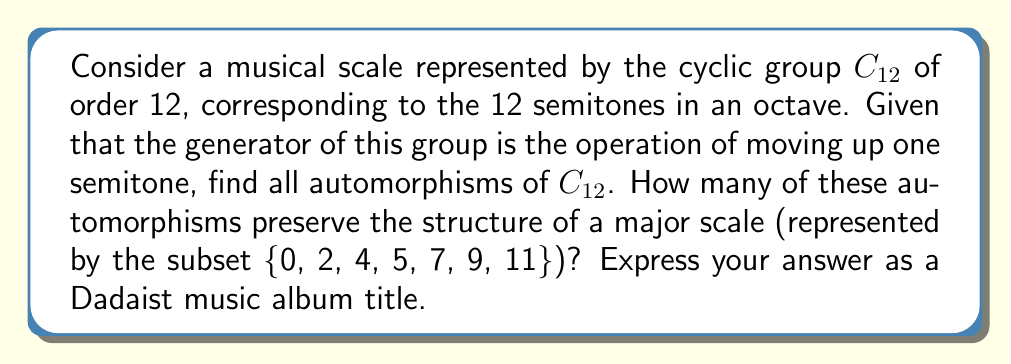Can you solve this math problem? Let's approach this step-by-step:

1) First, recall that for a cyclic group $C_n$, the automorphisms are precisely the mappings $\phi_k: x \mapsto x^k$, where $k$ is coprime to $n$.

2) In our case, $n = 12$. The numbers coprime to 12 are 1, 5, 7, and 11.

3) So, the automorphisms of $C_{12}$ are:
   $\phi_1: x \mapsto x^1 = x$ (the identity automorphism)
   $\phi_5: x \mapsto x^5$
   $\phi_7: x \mapsto x^7$
   $\phi_{11}: x \mapsto x^{11} = x^{-1}$

4) Now, let's consider which of these preserve the structure of a major scale {0, 2, 4, 5, 7, 9, 11}.

   $\phi_1$ obviously preserves it.
   
   $\phi_5$ maps the scale to {0, 10, 8, 1, 11, 9, 7}, which is not a major scale.
   
   $\phi_7$ maps the scale to {0, 2, 4, 11, 1, 3, 5}, which is not a major scale.
   
   $\phi_{11}$ maps the scale to {0, 10, 8, 7, 5, 3, 1}, which is the original scale in reverse order, and thus preserves the structure of a major scale.

5) Therefore, only 2 automorphisms ($\phi_1$ and $\phi_{11}$) preserve the structure of a major scale.

6) To express this as a Dadaist album title, we could use "2 Twisted Echoes in the Dodecaphonic Void".
Answer: 2 Twisted Echoes in the Dodecaphonic Void 